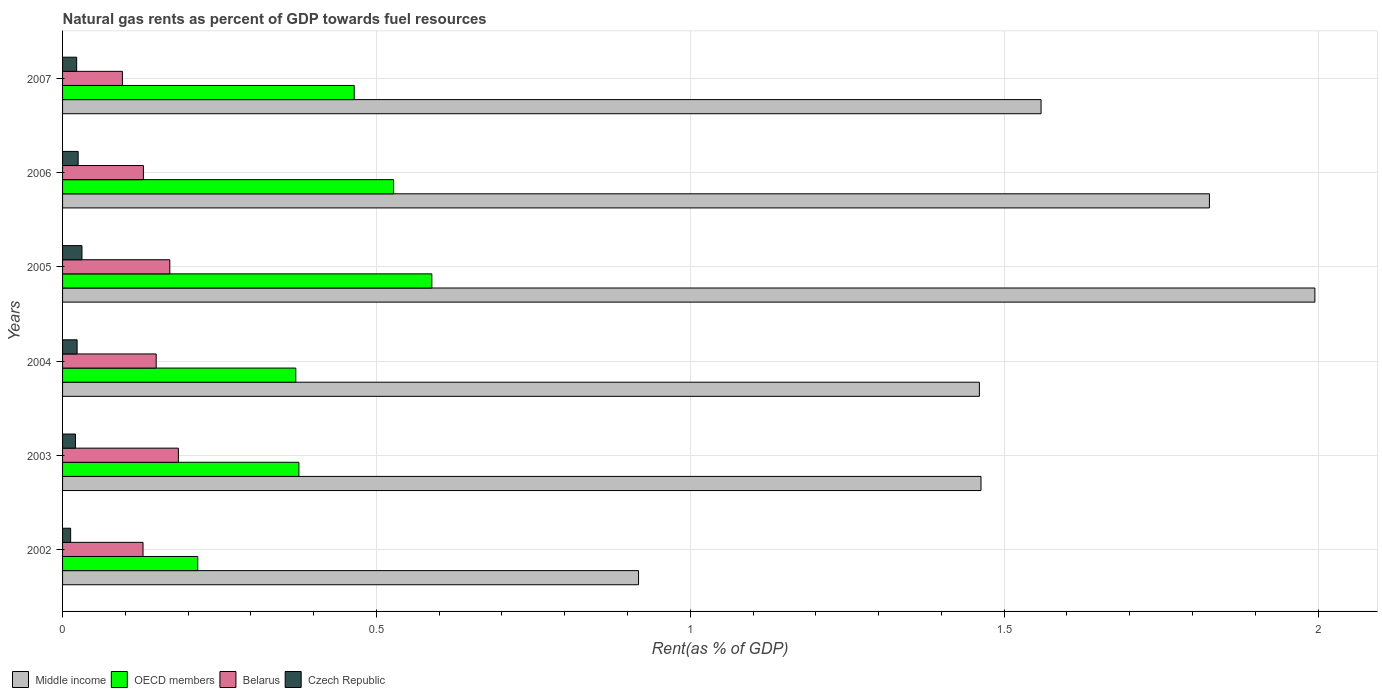How many different coloured bars are there?
Keep it short and to the point. 4. How many groups of bars are there?
Ensure brevity in your answer.  6. Are the number of bars per tick equal to the number of legend labels?
Give a very brief answer. Yes. Are the number of bars on each tick of the Y-axis equal?
Your response must be concise. Yes. How many bars are there on the 3rd tick from the top?
Your answer should be compact. 4. What is the matural gas rent in Czech Republic in 2007?
Offer a terse response. 0.02. Across all years, what is the maximum matural gas rent in Middle income?
Your answer should be compact. 1.99. Across all years, what is the minimum matural gas rent in OECD members?
Keep it short and to the point. 0.22. In which year was the matural gas rent in OECD members maximum?
Keep it short and to the point. 2005. In which year was the matural gas rent in OECD members minimum?
Your answer should be compact. 2002. What is the total matural gas rent in OECD members in the graph?
Provide a succinct answer. 2.54. What is the difference between the matural gas rent in Czech Republic in 2006 and that in 2007?
Offer a very short reply. 0. What is the difference between the matural gas rent in Middle income in 2006 and the matural gas rent in OECD members in 2003?
Your response must be concise. 1.45. What is the average matural gas rent in Czech Republic per year?
Your answer should be compact. 0.02. In the year 2003, what is the difference between the matural gas rent in Middle income and matural gas rent in Czech Republic?
Your response must be concise. 1.44. In how many years, is the matural gas rent in OECD members greater than 0.30000000000000004 %?
Your answer should be very brief. 5. What is the ratio of the matural gas rent in Czech Republic in 2005 to that in 2007?
Provide a short and direct response. 1.38. What is the difference between the highest and the second highest matural gas rent in Middle income?
Offer a terse response. 0.17. What is the difference between the highest and the lowest matural gas rent in Middle income?
Your answer should be very brief. 1.08. Is the sum of the matural gas rent in Czech Republic in 2005 and 2006 greater than the maximum matural gas rent in Belarus across all years?
Your answer should be compact. No. Is it the case that in every year, the sum of the matural gas rent in Middle income and matural gas rent in Belarus is greater than the sum of matural gas rent in OECD members and matural gas rent in Czech Republic?
Make the answer very short. Yes. What does the 3rd bar from the top in 2007 represents?
Offer a terse response. OECD members. What does the 3rd bar from the bottom in 2007 represents?
Provide a succinct answer. Belarus. Is it the case that in every year, the sum of the matural gas rent in Belarus and matural gas rent in Middle income is greater than the matural gas rent in OECD members?
Give a very brief answer. Yes. Are all the bars in the graph horizontal?
Ensure brevity in your answer.  Yes. How many years are there in the graph?
Your response must be concise. 6. What is the title of the graph?
Keep it short and to the point. Natural gas rents as percent of GDP towards fuel resources. Does "Jordan" appear as one of the legend labels in the graph?
Keep it short and to the point. No. What is the label or title of the X-axis?
Offer a terse response. Rent(as % of GDP). What is the label or title of the Y-axis?
Provide a succinct answer. Years. What is the Rent(as % of GDP) of Middle income in 2002?
Offer a terse response. 0.92. What is the Rent(as % of GDP) in OECD members in 2002?
Provide a succinct answer. 0.22. What is the Rent(as % of GDP) of Belarus in 2002?
Ensure brevity in your answer.  0.13. What is the Rent(as % of GDP) in Czech Republic in 2002?
Offer a terse response. 0.01. What is the Rent(as % of GDP) of Middle income in 2003?
Keep it short and to the point. 1.46. What is the Rent(as % of GDP) in OECD members in 2003?
Give a very brief answer. 0.38. What is the Rent(as % of GDP) in Belarus in 2003?
Offer a very short reply. 0.18. What is the Rent(as % of GDP) of Czech Republic in 2003?
Provide a succinct answer. 0.02. What is the Rent(as % of GDP) of Middle income in 2004?
Your answer should be compact. 1.46. What is the Rent(as % of GDP) in OECD members in 2004?
Provide a short and direct response. 0.37. What is the Rent(as % of GDP) of Belarus in 2004?
Your answer should be very brief. 0.15. What is the Rent(as % of GDP) of Czech Republic in 2004?
Your response must be concise. 0.02. What is the Rent(as % of GDP) of Middle income in 2005?
Keep it short and to the point. 1.99. What is the Rent(as % of GDP) of OECD members in 2005?
Make the answer very short. 0.59. What is the Rent(as % of GDP) in Belarus in 2005?
Your answer should be very brief. 0.17. What is the Rent(as % of GDP) in Czech Republic in 2005?
Provide a short and direct response. 0.03. What is the Rent(as % of GDP) of Middle income in 2006?
Ensure brevity in your answer.  1.83. What is the Rent(as % of GDP) in OECD members in 2006?
Make the answer very short. 0.53. What is the Rent(as % of GDP) of Belarus in 2006?
Keep it short and to the point. 0.13. What is the Rent(as % of GDP) in Czech Republic in 2006?
Offer a terse response. 0.02. What is the Rent(as % of GDP) of Middle income in 2007?
Offer a very short reply. 1.56. What is the Rent(as % of GDP) of OECD members in 2007?
Give a very brief answer. 0.46. What is the Rent(as % of GDP) of Belarus in 2007?
Make the answer very short. 0.1. What is the Rent(as % of GDP) in Czech Republic in 2007?
Offer a terse response. 0.02. Across all years, what is the maximum Rent(as % of GDP) of Middle income?
Give a very brief answer. 1.99. Across all years, what is the maximum Rent(as % of GDP) of OECD members?
Ensure brevity in your answer.  0.59. Across all years, what is the maximum Rent(as % of GDP) in Belarus?
Provide a short and direct response. 0.18. Across all years, what is the maximum Rent(as % of GDP) of Czech Republic?
Offer a very short reply. 0.03. Across all years, what is the minimum Rent(as % of GDP) in Middle income?
Ensure brevity in your answer.  0.92. Across all years, what is the minimum Rent(as % of GDP) in OECD members?
Offer a terse response. 0.22. Across all years, what is the minimum Rent(as % of GDP) of Belarus?
Offer a very short reply. 0.1. Across all years, what is the minimum Rent(as % of GDP) of Czech Republic?
Keep it short and to the point. 0.01. What is the total Rent(as % of GDP) in Middle income in the graph?
Your answer should be very brief. 9.22. What is the total Rent(as % of GDP) in OECD members in the graph?
Provide a short and direct response. 2.54. What is the total Rent(as % of GDP) in Belarus in the graph?
Make the answer very short. 0.86. What is the total Rent(as % of GDP) of Czech Republic in the graph?
Ensure brevity in your answer.  0.13. What is the difference between the Rent(as % of GDP) in Middle income in 2002 and that in 2003?
Your answer should be compact. -0.55. What is the difference between the Rent(as % of GDP) of OECD members in 2002 and that in 2003?
Keep it short and to the point. -0.16. What is the difference between the Rent(as % of GDP) of Belarus in 2002 and that in 2003?
Provide a short and direct response. -0.06. What is the difference between the Rent(as % of GDP) in Czech Republic in 2002 and that in 2003?
Your answer should be very brief. -0.01. What is the difference between the Rent(as % of GDP) of Middle income in 2002 and that in 2004?
Ensure brevity in your answer.  -0.54. What is the difference between the Rent(as % of GDP) in OECD members in 2002 and that in 2004?
Keep it short and to the point. -0.16. What is the difference between the Rent(as % of GDP) of Belarus in 2002 and that in 2004?
Your response must be concise. -0.02. What is the difference between the Rent(as % of GDP) of Czech Republic in 2002 and that in 2004?
Give a very brief answer. -0.01. What is the difference between the Rent(as % of GDP) of Middle income in 2002 and that in 2005?
Make the answer very short. -1.08. What is the difference between the Rent(as % of GDP) of OECD members in 2002 and that in 2005?
Make the answer very short. -0.37. What is the difference between the Rent(as % of GDP) of Belarus in 2002 and that in 2005?
Provide a short and direct response. -0.04. What is the difference between the Rent(as % of GDP) of Czech Republic in 2002 and that in 2005?
Provide a short and direct response. -0.02. What is the difference between the Rent(as % of GDP) in Middle income in 2002 and that in 2006?
Ensure brevity in your answer.  -0.91. What is the difference between the Rent(as % of GDP) in OECD members in 2002 and that in 2006?
Your answer should be compact. -0.31. What is the difference between the Rent(as % of GDP) in Belarus in 2002 and that in 2006?
Offer a very short reply. -0. What is the difference between the Rent(as % of GDP) in Czech Republic in 2002 and that in 2006?
Provide a short and direct response. -0.01. What is the difference between the Rent(as % of GDP) of Middle income in 2002 and that in 2007?
Keep it short and to the point. -0.64. What is the difference between the Rent(as % of GDP) of OECD members in 2002 and that in 2007?
Keep it short and to the point. -0.25. What is the difference between the Rent(as % of GDP) of Belarus in 2002 and that in 2007?
Give a very brief answer. 0.03. What is the difference between the Rent(as % of GDP) in Czech Republic in 2002 and that in 2007?
Make the answer very short. -0.01. What is the difference between the Rent(as % of GDP) in Middle income in 2003 and that in 2004?
Ensure brevity in your answer.  0. What is the difference between the Rent(as % of GDP) in OECD members in 2003 and that in 2004?
Your answer should be compact. 0.01. What is the difference between the Rent(as % of GDP) of Belarus in 2003 and that in 2004?
Your response must be concise. 0.04. What is the difference between the Rent(as % of GDP) of Czech Republic in 2003 and that in 2004?
Offer a very short reply. -0. What is the difference between the Rent(as % of GDP) in Middle income in 2003 and that in 2005?
Give a very brief answer. -0.53. What is the difference between the Rent(as % of GDP) in OECD members in 2003 and that in 2005?
Offer a very short reply. -0.21. What is the difference between the Rent(as % of GDP) in Belarus in 2003 and that in 2005?
Your response must be concise. 0.01. What is the difference between the Rent(as % of GDP) of Czech Republic in 2003 and that in 2005?
Offer a terse response. -0.01. What is the difference between the Rent(as % of GDP) in Middle income in 2003 and that in 2006?
Offer a terse response. -0.36. What is the difference between the Rent(as % of GDP) of OECD members in 2003 and that in 2006?
Give a very brief answer. -0.15. What is the difference between the Rent(as % of GDP) of Belarus in 2003 and that in 2006?
Make the answer very short. 0.06. What is the difference between the Rent(as % of GDP) in Czech Republic in 2003 and that in 2006?
Keep it short and to the point. -0. What is the difference between the Rent(as % of GDP) in Middle income in 2003 and that in 2007?
Your answer should be very brief. -0.1. What is the difference between the Rent(as % of GDP) of OECD members in 2003 and that in 2007?
Offer a terse response. -0.09. What is the difference between the Rent(as % of GDP) of Belarus in 2003 and that in 2007?
Provide a succinct answer. 0.09. What is the difference between the Rent(as % of GDP) in Czech Republic in 2003 and that in 2007?
Provide a succinct answer. -0. What is the difference between the Rent(as % of GDP) in Middle income in 2004 and that in 2005?
Your response must be concise. -0.53. What is the difference between the Rent(as % of GDP) of OECD members in 2004 and that in 2005?
Offer a very short reply. -0.22. What is the difference between the Rent(as % of GDP) of Belarus in 2004 and that in 2005?
Provide a short and direct response. -0.02. What is the difference between the Rent(as % of GDP) in Czech Republic in 2004 and that in 2005?
Ensure brevity in your answer.  -0.01. What is the difference between the Rent(as % of GDP) in Middle income in 2004 and that in 2006?
Offer a terse response. -0.37. What is the difference between the Rent(as % of GDP) of OECD members in 2004 and that in 2006?
Offer a very short reply. -0.16. What is the difference between the Rent(as % of GDP) in Belarus in 2004 and that in 2006?
Keep it short and to the point. 0.02. What is the difference between the Rent(as % of GDP) of Czech Republic in 2004 and that in 2006?
Make the answer very short. -0. What is the difference between the Rent(as % of GDP) in Middle income in 2004 and that in 2007?
Keep it short and to the point. -0.1. What is the difference between the Rent(as % of GDP) of OECD members in 2004 and that in 2007?
Keep it short and to the point. -0.09. What is the difference between the Rent(as % of GDP) of Belarus in 2004 and that in 2007?
Provide a short and direct response. 0.05. What is the difference between the Rent(as % of GDP) in Czech Republic in 2004 and that in 2007?
Provide a short and direct response. 0. What is the difference between the Rent(as % of GDP) in Middle income in 2005 and that in 2006?
Make the answer very short. 0.17. What is the difference between the Rent(as % of GDP) in OECD members in 2005 and that in 2006?
Provide a succinct answer. 0.06. What is the difference between the Rent(as % of GDP) of Belarus in 2005 and that in 2006?
Give a very brief answer. 0.04. What is the difference between the Rent(as % of GDP) of Czech Republic in 2005 and that in 2006?
Keep it short and to the point. 0.01. What is the difference between the Rent(as % of GDP) of Middle income in 2005 and that in 2007?
Provide a short and direct response. 0.44. What is the difference between the Rent(as % of GDP) of OECD members in 2005 and that in 2007?
Your answer should be compact. 0.12. What is the difference between the Rent(as % of GDP) in Belarus in 2005 and that in 2007?
Offer a terse response. 0.08. What is the difference between the Rent(as % of GDP) of Czech Republic in 2005 and that in 2007?
Offer a terse response. 0.01. What is the difference between the Rent(as % of GDP) of Middle income in 2006 and that in 2007?
Offer a very short reply. 0.27. What is the difference between the Rent(as % of GDP) of OECD members in 2006 and that in 2007?
Your answer should be compact. 0.06. What is the difference between the Rent(as % of GDP) in Belarus in 2006 and that in 2007?
Offer a terse response. 0.03. What is the difference between the Rent(as % of GDP) in Czech Republic in 2006 and that in 2007?
Your answer should be very brief. 0. What is the difference between the Rent(as % of GDP) of Middle income in 2002 and the Rent(as % of GDP) of OECD members in 2003?
Offer a very short reply. 0.54. What is the difference between the Rent(as % of GDP) in Middle income in 2002 and the Rent(as % of GDP) in Belarus in 2003?
Your response must be concise. 0.73. What is the difference between the Rent(as % of GDP) of Middle income in 2002 and the Rent(as % of GDP) of Czech Republic in 2003?
Provide a short and direct response. 0.9. What is the difference between the Rent(as % of GDP) in OECD members in 2002 and the Rent(as % of GDP) in Belarus in 2003?
Keep it short and to the point. 0.03. What is the difference between the Rent(as % of GDP) of OECD members in 2002 and the Rent(as % of GDP) of Czech Republic in 2003?
Provide a succinct answer. 0.19. What is the difference between the Rent(as % of GDP) of Belarus in 2002 and the Rent(as % of GDP) of Czech Republic in 2003?
Ensure brevity in your answer.  0.11. What is the difference between the Rent(as % of GDP) in Middle income in 2002 and the Rent(as % of GDP) in OECD members in 2004?
Provide a short and direct response. 0.55. What is the difference between the Rent(as % of GDP) of Middle income in 2002 and the Rent(as % of GDP) of Belarus in 2004?
Offer a very short reply. 0.77. What is the difference between the Rent(as % of GDP) of Middle income in 2002 and the Rent(as % of GDP) of Czech Republic in 2004?
Your response must be concise. 0.89. What is the difference between the Rent(as % of GDP) in OECD members in 2002 and the Rent(as % of GDP) in Belarus in 2004?
Provide a succinct answer. 0.07. What is the difference between the Rent(as % of GDP) in OECD members in 2002 and the Rent(as % of GDP) in Czech Republic in 2004?
Your answer should be compact. 0.19. What is the difference between the Rent(as % of GDP) of Belarus in 2002 and the Rent(as % of GDP) of Czech Republic in 2004?
Give a very brief answer. 0.1. What is the difference between the Rent(as % of GDP) of Middle income in 2002 and the Rent(as % of GDP) of OECD members in 2005?
Provide a short and direct response. 0.33. What is the difference between the Rent(as % of GDP) in Middle income in 2002 and the Rent(as % of GDP) in Belarus in 2005?
Keep it short and to the point. 0.75. What is the difference between the Rent(as % of GDP) in Middle income in 2002 and the Rent(as % of GDP) in Czech Republic in 2005?
Make the answer very short. 0.89. What is the difference between the Rent(as % of GDP) in OECD members in 2002 and the Rent(as % of GDP) in Belarus in 2005?
Keep it short and to the point. 0.04. What is the difference between the Rent(as % of GDP) in OECD members in 2002 and the Rent(as % of GDP) in Czech Republic in 2005?
Your answer should be compact. 0.18. What is the difference between the Rent(as % of GDP) of Belarus in 2002 and the Rent(as % of GDP) of Czech Republic in 2005?
Provide a succinct answer. 0.1. What is the difference between the Rent(as % of GDP) of Middle income in 2002 and the Rent(as % of GDP) of OECD members in 2006?
Provide a short and direct response. 0.39. What is the difference between the Rent(as % of GDP) of Middle income in 2002 and the Rent(as % of GDP) of Belarus in 2006?
Your response must be concise. 0.79. What is the difference between the Rent(as % of GDP) in Middle income in 2002 and the Rent(as % of GDP) in Czech Republic in 2006?
Offer a terse response. 0.89. What is the difference between the Rent(as % of GDP) of OECD members in 2002 and the Rent(as % of GDP) of Belarus in 2006?
Provide a succinct answer. 0.09. What is the difference between the Rent(as % of GDP) in OECD members in 2002 and the Rent(as % of GDP) in Czech Republic in 2006?
Offer a very short reply. 0.19. What is the difference between the Rent(as % of GDP) in Belarus in 2002 and the Rent(as % of GDP) in Czech Republic in 2006?
Offer a terse response. 0.1. What is the difference between the Rent(as % of GDP) in Middle income in 2002 and the Rent(as % of GDP) in OECD members in 2007?
Ensure brevity in your answer.  0.45. What is the difference between the Rent(as % of GDP) in Middle income in 2002 and the Rent(as % of GDP) in Belarus in 2007?
Provide a short and direct response. 0.82. What is the difference between the Rent(as % of GDP) of Middle income in 2002 and the Rent(as % of GDP) of Czech Republic in 2007?
Ensure brevity in your answer.  0.9. What is the difference between the Rent(as % of GDP) of OECD members in 2002 and the Rent(as % of GDP) of Belarus in 2007?
Offer a very short reply. 0.12. What is the difference between the Rent(as % of GDP) of OECD members in 2002 and the Rent(as % of GDP) of Czech Republic in 2007?
Keep it short and to the point. 0.19. What is the difference between the Rent(as % of GDP) in Belarus in 2002 and the Rent(as % of GDP) in Czech Republic in 2007?
Give a very brief answer. 0.11. What is the difference between the Rent(as % of GDP) of Middle income in 2003 and the Rent(as % of GDP) of OECD members in 2004?
Ensure brevity in your answer.  1.09. What is the difference between the Rent(as % of GDP) of Middle income in 2003 and the Rent(as % of GDP) of Belarus in 2004?
Ensure brevity in your answer.  1.31. What is the difference between the Rent(as % of GDP) of Middle income in 2003 and the Rent(as % of GDP) of Czech Republic in 2004?
Provide a short and direct response. 1.44. What is the difference between the Rent(as % of GDP) of OECD members in 2003 and the Rent(as % of GDP) of Belarus in 2004?
Offer a very short reply. 0.23. What is the difference between the Rent(as % of GDP) in OECD members in 2003 and the Rent(as % of GDP) in Czech Republic in 2004?
Keep it short and to the point. 0.35. What is the difference between the Rent(as % of GDP) in Belarus in 2003 and the Rent(as % of GDP) in Czech Republic in 2004?
Provide a succinct answer. 0.16. What is the difference between the Rent(as % of GDP) in Middle income in 2003 and the Rent(as % of GDP) in OECD members in 2005?
Provide a succinct answer. 0.87. What is the difference between the Rent(as % of GDP) of Middle income in 2003 and the Rent(as % of GDP) of Belarus in 2005?
Ensure brevity in your answer.  1.29. What is the difference between the Rent(as % of GDP) of Middle income in 2003 and the Rent(as % of GDP) of Czech Republic in 2005?
Offer a very short reply. 1.43. What is the difference between the Rent(as % of GDP) of OECD members in 2003 and the Rent(as % of GDP) of Belarus in 2005?
Offer a very short reply. 0.21. What is the difference between the Rent(as % of GDP) of OECD members in 2003 and the Rent(as % of GDP) of Czech Republic in 2005?
Offer a very short reply. 0.35. What is the difference between the Rent(as % of GDP) in Belarus in 2003 and the Rent(as % of GDP) in Czech Republic in 2005?
Your answer should be compact. 0.15. What is the difference between the Rent(as % of GDP) in Middle income in 2003 and the Rent(as % of GDP) in OECD members in 2006?
Provide a short and direct response. 0.94. What is the difference between the Rent(as % of GDP) of Middle income in 2003 and the Rent(as % of GDP) of Belarus in 2006?
Keep it short and to the point. 1.33. What is the difference between the Rent(as % of GDP) in Middle income in 2003 and the Rent(as % of GDP) in Czech Republic in 2006?
Make the answer very short. 1.44. What is the difference between the Rent(as % of GDP) of OECD members in 2003 and the Rent(as % of GDP) of Belarus in 2006?
Your response must be concise. 0.25. What is the difference between the Rent(as % of GDP) of OECD members in 2003 and the Rent(as % of GDP) of Czech Republic in 2006?
Your answer should be compact. 0.35. What is the difference between the Rent(as % of GDP) in Belarus in 2003 and the Rent(as % of GDP) in Czech Republic in 2006?
Offer a very short reply. 0.16. What is the difference between the Rent(as % of GDP) in Middle income in 2003 and the Rent(as % of GDP) in Belarus in 2007?
Your response must be concise. 1.37. What is the difference between the Rent(as % of GDP) of Middle income in 2003 and the Rent(as % of GDP) of Czech Republic in 2007?
Your answer should be very brief. 1.44. What is the difference between the Rent(as % of GDP) in OECD members in 2003 and the Rent(as % of GDP) in Belarus in 2007?
Ensure brevity in your answer.  0.28. What is the difference between the Rent(as % of GDP) in OECD members in 2003 and the Rent(as % of GDP) in Czech Republic in 2007?
Keep it short and to the point. 0.35. What is the difference between the Rent(as % of GDP) of Belarus in 2003 and the Rent(as % of GDP) of Czech Republic in 2007?
Keep it short and to the point. 0.16. What is the difference between the Rent(as % of GDP) in Middle income in 2004 and the Rent(as % of GDP) in OECD members in 2005?
Make the answer very short. 0.87. What is the difference between the Rent(as % of GDP) in Middle income in 2004 and the Rent(as % of GDP) in Belarus in 2005?
Keep it short and to the point. 1.29. What is the difference between the Rent(as % of GDP) in Middle income in 2004 and the Rent(as % of GDP) in Czech Republic in 2005?
Provide a succinct answer. 1.43. What is the difference between the Rent(as % of GDP) of OECD members in 2004 and the Rent(as % of GDP) of Belarus in 2005?
Keep it short and to the point. 0.2. What is the difference between the Rent(as % of GDP) in OECD members in 2004 and the Rent(as % of GDP) in Czech Republic in 2005?
Offer a very short reply. 0.34. What is the difference between the Rent(as % of GDP) in Belarus in 2004 and the Rent(as % of GDP) in Czech Republic in 2005?
Give a very brief answer. 0.12. What is the difference between the Rent(as % of GDP) in Middle income in 2004 and the Rent(as % of GDP) in OECD members in 2006?
Your answer should be compact. 0.93. What is the difference between the Rent(as % of GDP) of Middle income in 2004 and the Rent(as % of GDP) of Belarus in 2006?
Offer a terse response. 1.33. What is the difference between the Rent(as % of GDP) of Middle income in 2004 and the Rent(as % of GDP) of Czech Republic in 2006?
Give a very brief answer. 1.44. What is the difference between the Rent(as % of GDP) of OECD members in 2004 and the Rent(as % of GDP) of Belarus in 2006?
Your answer should be compact. 0.24. What is the difference between the Rent(as % of GDP) of OECD members in 2004 and the Rent(as % of GDP) of Czech Republic in 2006?
Offer a terse response. 0.35. What is the difference between the Rent(as % of GDP) in Belarus in 2004 and the Rent(as % of GDP) in Czech Republic in 2006?
Offer a terse response. 0.12. What is the difference between the Rent(as % of GDP) in Middle income in 2004 and the Rent(as % of GDP) in OECD members in 2007?
Keep it short and to the point. 1. What is the difference between the Rent(as % of GDP) of Middle income in 2004 and the Rent(as % of GDP) of Belarus in 2007?
Provide a short and direct response. 1.37. What is the difference between the Rent(as % of GDP) of Middle income in 2004 and the Rent(as % of GDP) of Czech Republic in 2007?
Your response must be concise. 1.44. What is the difference between the Rent(as % of GDP) of OECD members in 2004 and the Rent(as % of GDP) of Belarus in 2007?
Offer a terse response. 0.28. What is the difference between the Rent(as % of GDP) in OECD members in 2004 and the Rent(as % of GDP) in Czech Republic in 2007?
Keep it short and to the point. 0.35. What is the difference between the Rent(as % of GDP) in Belarus in 2004 and the Rent(as % of GDP) in Czech Republic in 2007?
Offer a very short reply. 0.13. What is the difference between the Rent(as % of GDP) of Middle income in 2005 and the Rent(as % of GDP) of OECD members in 2006?
Offer a terse response. 1.47. What is the difference between the Rent(as % of GDP) of Middle income in 2005 and the Rent(as % of GDP) of Belarus in 2006?
Keep it short and to the point. 1.87. What is the difference between the Rent(as % of GDP) in Middle income in 2005 and the Rent(as % of GDP) in Czech Republic in 2006?
Your response must be concise. 1.97. What is the difference between the Rent(as % of GDP) in OECD members in 2005 and the Rent(as % of GDP) in Belarus in 2006?
Your answer should be compact. 0.46. What is the difference between the Rent(as % of GDP) in OECD members in 2005 and the Rent(as % of GDP) in Czech Republic in 2006?
Provide a short and direct response. 0.56. What is the difference between the Rent(as % of GDP) in Belarus in 2005 and the Rent(as % of GDP) in Czech Republic in 2006?
Your answer should be very brief. 0.15. What is the difference between the Rent(as % of GDP) in Middle income in 2005 and the Rent(as % of GDP) in OECD members in 2007?
Your answer should be very brief. 1.53. What is the difference between the Rent(as % of GDP) of Middle income in 2005 and the Rent(as % of GDP) of Belarus in 2007?
Your answer should be compact. 1.9. What is the difference between the Rent(as % of GDP) in Middle income in 2005 and the Rent(as % of GDP) in Czech Republic in 2007?
Provide a short and direct response. 1.97. What is the difference between the Rent(as % of GDP) in OECD members in 2005 and the Rent(as % of GDP) in Belarus in 2007?
Your response must be concise. 0.49. What is the difference between the Rent(as % of GDP) in OECD members in 2005 and the Rent(as % of GDP) in Czech Republic in 2007?
Provide a short and direct response. 0.57. What is the difference between the Rent(as % of GDP) in Belarus in 2005 and the Rent(as % of GDP) in Czech Republic in 2007?
Offer a terse response. 0.15. What is the difference between the Rent(as % of GDP) of Middle income in 2006 and the Rent(as % of GDP) of OECD members in 2007?
Offer a terse response. 1.36. What is the difference between the Rent(as % of GDP) in Middle income in 2006 and the Rent(as % of GDP) in Belarus in 2007?
Make the answer very short. 1.73. What is the difference between the Rent(as % of GDP) of Middle income in 2006 and the Rent(as % of GDP) of Czech Republic in 2007?
Ensure brevity in your answer.  1.8. What is the difference between the Rent(as % of GDP) in OECD members in 2006 and the Rent(as % of GDP) in Belarus in 2007?
Provide a short and direct response. 0.43. What is the difference between the Rent(as % of GDP) of OECD members in 2006 and the Rent(as % of GDP) of Czech Republic in 2007?
Keep it short and to the point. 0.5. What is the difference between the Rent(as % of GDP) of Belarus in 2006 and the Rent(as % of GDP) of Czech Republic in 2007?
Give a very brief answer. 0.11. What is the average Rent(as % of GDP) in Middle income per year?
Offer a very short reply. 1.54. What is the average Rent(as % of GDP) in OECD members per year?
Offer a very short reply. 0.42. What is the average Rent(as % of GDP) in Belarus per year?
Offer a very short reply. 0.14. What is the average Rent(as % of GDP) in Czech Republic per year?
Give a very brief answer. 0.02. In the year 2002, what is the difference between the Rent(as % of GDP) of Middle income and Rent(as % of GDP) of OECD members?
Offer a very short reply. 0.7. In the year 2002, what is the difference between the Rent(as % of GDP) in Middle income and Rent(as % of GDP) in Belarus?
Provide a succinct answer. 0.79. In the year 2002, what is the difference between the Rent(as % of GDP) in Middle income and Rent(as % of GDP) in Czech Republic?
Provide a short and direct response. 0.9. In the year 2002, what is the difference between the Rent(as % of GDP) of OECD members and Rent(as % of GDP) of Belarus?
Your answer should be very brief. 0.09. In the year 2002, what is the difference between the Rent(as % of GDP) in OECD members and Rent(as % of GDP) in Czech Republic?
Your answer should be very brief. 0.2. In the year 2002, what is the difference between the Rent(as % of GDP) of Belarus and Rent(as % of GDP) of Czech Republic?
Provide a short and direct response. 0.12. In the year 2003, what is the difference between the Rent(as % of GDP) of Middle income and Rent(as % of GDP) of OECD members?
Provide a succinct answer. 1.09. In the year 2003, what is the difference between the Rent(as % of GDP) of Middle income and Rent(as % of GDP) of Belarus?
Your answer should be very brief. 1.28. In the year 2003, what is the difference between the Rent(as % of GDP) of Middle income and Rent(as % of GDP) of Czech Republic?
Provide a short and direct response. 1.44. In the year 2003, what is the difference between the Rent(as % of GDP) of OECD members and Rent(as % of GDP) of Belarus?
Provide a short and direct response. 0.19. In the year 2003, what is the difference between the Rent(as % of GDP) in OECD members and Rent(as % of GDP) in Czech Republic?
Offer a terse response. 0.36. In the year 2003, what is the difference between the Rent(as % of GDP) in Belarus and Rent(as % of GDP) in Czech Republic?
Offer a very short reply. 0.16. In the year 2004, what is the difference between the Rent(as % of GDP) of Middle income and Rent(as % of GDP) of OECD members?
Keep it short and to the point. 1.09. In the year 2004, what is the difference between the Rent(as % of GDP) in Middle income and Rent(as % of GDP) in Belarus?
Your response must be concise. 1.31. In the year 2004, what is the difference between the Rent(as % of GDP) of Middle income and Rent(as % of GDP) of Czech Republic?
Ensure brevity in your answer.  1.44. In the year 2004, what is the difference between the Rent(as % of GDP) of OECD members and Rent(as % of GDP) of Belarus?
Keep it short and to the point. 0.22. In the year 2004, what is the difference between the Rent(as % of GDP) of OECD members and Rent(as % of GDP) of Czech Republic?
Ensure brevity in your answer.  0.35. In the year 2004, what is the difference between the Rent(as % of GDP) in Belarus and Rent(as % of GDP) in Czech Republic?
Give a very brief answer. 0.13. In the year 2005, what is the difference between the Rent(as % of GDP) in Middle income and Rent(as % of GDP) in OECD members?
Provide a short and direct response. 1.41. In the year 2005, what is the difference between the Rent(as % of GDP) of Middle income and Rent(as % of GDP) of Belarus?
Ensure brevity in your answer.  1.82. In the year 2005, what is the difference between the Rent(as % of GDP) of Middle income and Rent(as % of GDP) of Czech Republic?
Keep it short and to the point. 1.96. In the year 2005, what is the difference between the Rent(as % of GDP) of OECD members and Rent(as % of GDP) of Belarus?
Your answer should be very brief. 0.42. In the year 2005, what is the difference between the Rent(as % of GDP) in OECD members and Rent(as % of GDP) in Czech Republic?
Your response must be concise. 0.56. In the year 2005, what is the difference between the Rent(as % of GDP) in Belarus and Rent(as % of GDP) in Czech Republic?
Offer a terse response. 0.14. In the year 2006, what is the difference between the Rent(as % of GDP) of Middle income and Rent(as % of GDP) of OECD members?
Your response must be concise. 1.3. In the year 2006, what is the difference between the Rent(as % of GDP) of Middle income and Rent(as % of GDP) of Belarus?
Make the answer very short. 1.7. In the year 2006, what is the difference between the Rent(as % of GDP) in Middle income and Rent(as % of GDP) in Czech Republic?
Ensure brevity in your answer.  1.8. In the year 2006, what is the difference between the Rent(as % of GDP) of OECD members and Rent(as % of GDP) of Belarus?
Your answer should be compact. 0.4. In the year 2006, what is the difference between the Rent(as % of GDP) in OECD members and Rent(as % of GDP) in Czech Republic?
Ensure brevity in your answer.  0.5. In the year 2006, what is the difference between the Rent(as % of GDP) of Belarus and Rent(as % of GDP) of Czech Republic?
Provide a succinct answer. 0.1. In the year 2007, what is the difference between the Rent(as % of GDP) in Middle income and Rent(as % of GDP) in OECD members?
Offer a terse response. 1.09. In the year 2007, what is the difference between the Rent(as % of GDP) in Middle income and Rent(as % of GDP) in Belarus?
Ensure brevity in your answer.  1.46. In the year 2007, what is the difference between the Rent(as % of GDP) of Middle income and Rent(as % of GDP) of Czech Republic?
Your answer should be compact. 1.54. In the year 2007, what is the difference between the Rent(as % of GDP) of OECD members and Rent(as % of GDP) of Belarus?
Keep it short and to the point. 0.37. In the year 2007, what is the difference between the Rent(as % of GDP) of OECD members and Rent(as % of GDP) of Czech Republic?
Your answer should be very brief. 0.44. In the year 2007, what is the difference between the Rent(as % of GDP) of Belarus and Rent(as % of GDP) of Czech Republic?
Give a very brief answer. 0.07. What is the ratio of the Rent(as % of GDP) in Middle income in 2002 to that in 2003?
Your answer should be compact. 0.63. What is the ratio of the Rent(as % of GDP) of OECD members in 2002 to that in 2003?
Offer a very short reply. 0.57. What is the ratio of the Rent(as % of GDP) in Belarus in 2002 to that in 2003?
Ensure brevity in your answer.  0.69. What is the ratio of the Rent(as % of GDP) of Czech Republic in 2002 to that in 2003?
Offer a very short reply. 0.62. What is the ratio of the Rent(as % of GDP) of Middle income in 2002 to that in 2004?
Your answer should be compact. 0.63. What is the ratio of the Rent(as % of GDP) in OECD members in 2002 to that in 2004?
Provide a succinct answer. 0.58. What is the ratio of the Rent(as % of GDP) in Belarus in 2002 to that in 2004?
Your answer should be very brief. 0.86. What is the ratio of the Rent(as % of GDP) of Czech Republic in 2002 to that in 2004?
Your response must be concise. 0.56. What is the ratio of the Rent(as % of GDP) of Middle income in 2002 to that in 2005?
Provide a short and direct response. 0.46. What is the ratio of the Rent(as % of GDP) of OECD members in 2002 to that in 2005?
Make the answer very short. 0.37. What is the ratio of the Rent(as % of GDP) of Belarus in 2002 to that in 2005?
Ensure brevity in your answer.  0.75. What is the ratio of the Rent(as % of GDP) in Czech Republic in 2002 to that in 2005?
Keep it short and to the point. 0.42. What is the ratio of the Rent(as % of GDP) of Middle income in 2002 to that in 2006?
Provide a short and direct response. 0.5. What is the ratio of the Rent(as % of GDP) in OECD members in 2002 to that in 2006?
Make the answer very short. 0.41. What is the ratio of the Rent(as % of GDP) of Czech Republic in 2002 to that in 2006?
Keep it short and to the point. 0.52. What is the ratio of the Rent(as % of GDP) in Middle income in 2002 to that in 2007?
Your response must be concise. 0.59. What is the ratio of the Rent(as % of GDP) of OECD members in 2002 to that in 2007?
Your answer should be compact. 0.46. What is the ratio of the Rent(as % of GDP) in Belarus in 2002 to that in 2007?
Your response must be concise. 1.34. What is the ratio of the Rent(as % of GDP) in Czech Republic in 2002 to that in 2007?
Provide a short and direct response. 0.57. What is the ratio of the Rent(as % of GDP) of Middle income in 2003 to that in 2004?
Ensure brevity in your answer.  1. What is the ratio of the Rent(as % of GDP) in OECD members in 2003 to that in 2004?
Offer a terse response. 1.01. What is the ratio of the Rent(as % of GDP) of Belarus in 2003 to that in 2004?
Your response must be concise. 1.24. What is the ratio of the Rent(as % of GDP) in Middle income in 2003 to that in 2005?
Make the answer very short. 0.73. What is the ratio of the Rent(as % of GDP) in OECD members in 2003 to that in 2005?
Offer a very short reply. 0.64. What is the ratio of the Rent(as % of GDP) of Czech Republic in 2003 to that in 2005?
Keep it short and to the point. 0.67. What is the ratio of the Rent(as % of GDP) of Middle income in 2003 to that in 2006?
Make the answer very short. 0.8. What is the ratio of the Rent(as % of GDP) in OECD members in 2003 to that in 2006?
Provide a short and direct response. 0.71. What is the ratio of the Rent(as % of GDP) of Belarus in 2003 to that in 2006?
Your answer should be very brief. 1.43. What is the ratio of the Rent(as % of GDP) of Czech Republic in 2003 to that in 2006?
Keep it short and to the point. 0.83. What is the ratio of the Rent(as % of GDP) in Middle income in 2003 to that in 2007?
Your answer should be compact. 0.94. What is the ratio of the Rent(as % of GDP) in OECD members in 2003 to that in 2007?
Make the answer very short. 0.81. What is the ratio of the Rent(as % of GDP) in Belarus in 2003 to that in 2007?
Offer a terse response. 1.94. What is the ratio of the Rent(as % of GDP) of Czech Republic in 2003 to that in 2007?
Make the answer very short. 0.92. What is the ratio of the Rent(as % of GDP) of Middle income in 2004 to that in 2005?
Provide a succinct answer. 0.73. What is the ratio of the Rent(as % of GDP) in OECD members in 2004 to that in 2005?
Your answer should be compact. 0.63. What is the ratio of the Rent(as % of GDP) in Belarus in 2004 to that in 2005?
Your answer should be very brief. 0.87. What is the ratio of the Rent(as % of GDP) of Czech Republic in 2004 to that in 2005?
Make the answer very short. 0.75. What is the ratio of the Rent(as % of GDP) in Middle income in 2004 to that in 2006?
Make the answer very short. 0.8. What is the ratio of the Rent(as % of GDP) in OECD members in 2004 to that in 2006?
Your answer should be very brief. 0.7. What is the ratio of the Rent(as % of GDP) in Belarus in 2004 to that in 2006?
Your answer should be compact. 1.16. What is the ratio of the Rent(as % of GDP) of Czech Republic in 2004 to that in 2006?
Offer a very short reply. 0.93. What is the ratio of the Rent(as % of GDP) of Middle income in 2004 to that in 2007?
Make the answer very short. 0.94. What is the ratio of the Rent(as % of GDP) of OECD members in 2004 to that in 2007?
Offer a very short reply. 0.8. What is the ratio of the Rent(as % of GDP) of Belarus in 2004 to that in 2007?
Keep it short and to the point. 1.56. What is the ratio of the Rent(as % of GDP) of Czech Republic in 2004 to that in 2007?
Offer a very short reply. 1.03. What is the ratio of the Rent(as % of GDP) of Middle income in 2005 to that in 2006?
Ensure brevity in your answer.  1.09. What is the ratio of the Rent(as % of GDP) in OECD members in 2005 to that in 2006?
Provide a short and direct response. 1.12. What is the ratio of the Rent(as % of GDP) in Belarus in 2005 to that in 2006?
Ensure brevity in your answer.  1.33. What is the ratio of the Rent(as % of GDP) of Czech Republic in 2005 to that in 2006?
Your response must be concise. 1.24. What is the ratio of the Rent(as % of GDP) of Middle income in 2005 to that in 2007?
Provide a succinct answer. 1.28. What is the ratio of the Rent(as % of GDP) in OECD members in 2005 to that in 2007?
Your response must be concise. 1.27. What is the ratio of the Rent(as % of GDP) in Belarus in 2005 to that in 2007?
Provide a succinct answer. 1.79. What is the ratio of the Rent(as % of GDP) of Czech Republic in 2005 to that in 2007?
Your answer should be compact. 1.38. What is the ratio of the Rent(as % of GDP) in Middle income in 2006 to that in 2007?
Your response must be concise. 1.17. What is the ratio of the Rent(as % of GDP) of OECD members in 2006 to that in 2007?
Your response must be concise. 1.14. What is the ratio of the Rent(as % of GDP) in Belarus in 2006 to that in 2007?
Offer a very short reply. 1.35. What is the ratio of the Rent(as % of GDP) in Czech Republic in 2006 to that in 2007?
Keep it short and to the point. 1.11. What is the difference between the highest and the second highest Rent(as % of GDP) in Middle income?
Offer a terse response. 0.17. What is the difference between the highest and the second highest Rent(as % of GDP) in OECD members?
Your answer should be very brief. 0.06. What is the difference between the highest and the second highest Rent(as % of GDP) in Belarus?
Provide a short and direct response. 0.01. What is the difference between the highest and the second highest Rent(as % of GDP) in Czech Republic?
Give a very brief answer. 0.01. What is the difference between the highest and the lowest Rent(as % of GDP) in Middle income?
Your response must be concise. 1.08. What is the difference between the highest and the lowest Rent(as % of GDP) of OECD members?
Your response must be concise. 0.37. What is the difference between the highest and the lowest Rent(as % of GDP) in Belarus?
Make the answer very short. 0.09. What is the difference between the highest and the lowest Rent(as % of GDP) of Czech Republic?
Offer a very short reply. 0.02. 